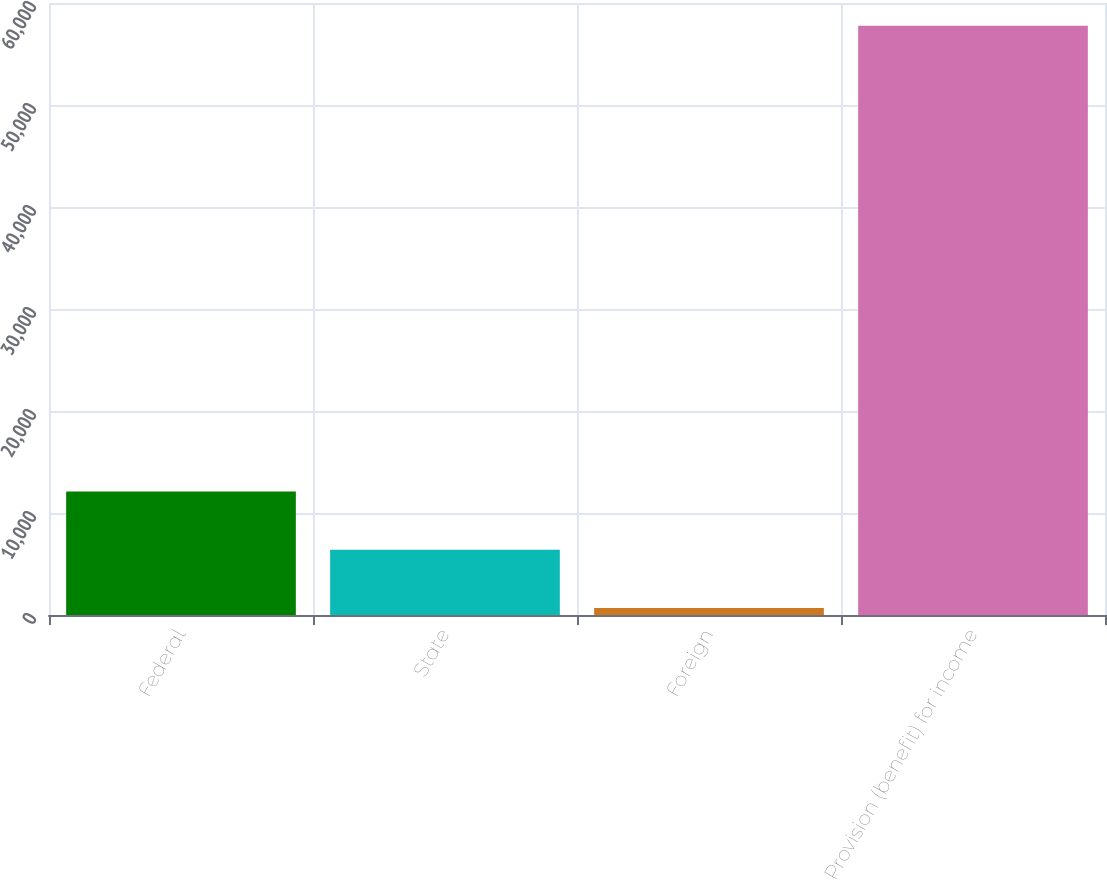<chart> <loc_0><loc_0><loc_500><loc_500><bar_chart><fcel>Federal<fcel>State<fcel>Foreign<fcel>Provision (benefit) for income<nl><fcel>12103.2<fcel>6393.6<fcel>684<fcel>57780<nl></chart> 